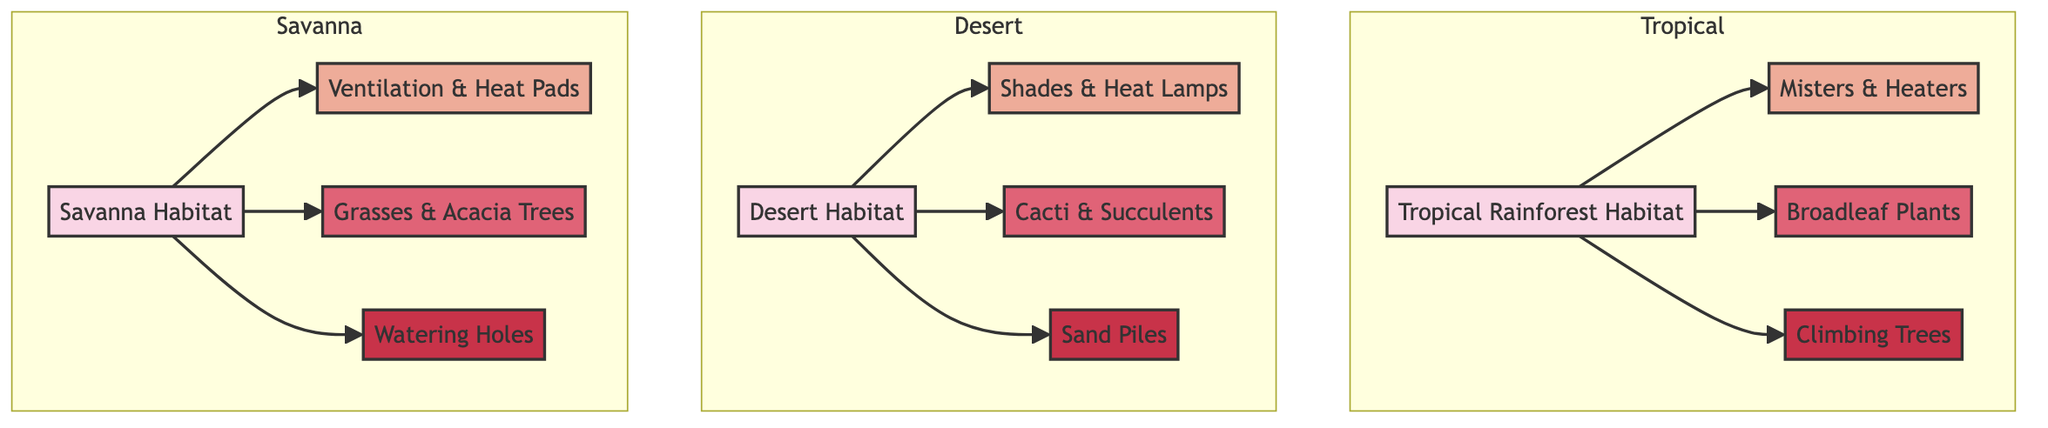What habitats are represented in the diagram? The diagram shows three habitats: Tropical Rainforest Habitat, Desert Habitat, and Savanna Habitat. These are clearly labeled as separate nodes on the diagram.
Answer: Tropical Rainforest, Desert, Savanna How many climate control methods are listed in the diagram? There are three climate control methods provided in the diagram, which are Misters & Heaters, Shades & Heat Lamps, and Ventilation & Heat Pads. Each method corresponds to a specific habitat.
Answer: 3 Which foliage is associated with the Desert Habitat? The Desert Habitat is linked to the Cacti & Succulents node as its specific foliage. This relationship is highlighted in the diagram.
Answer: Cacti & Succulents What type of enrichment activities are provided for the Tropical Rainforest Habitat? The Tropical Rainforest Habitat includes Climbing Trees as the enrichment activity, demonstrated through the direct connection in the diagram.
Answer: Climbing Trees Which habitat utilizes Ventilation & Heat Pads for climate control? The Savanna Habitat uses Ventilation & Heat Pads as its climate control method, as indicated by the direct link between the habitat and this climate control method in the diagram.
Answer: Savanna Habitat How many types of foliage are depicted in the diagram? The diagram shows three types of foliage, one for each habitat: Broadleaf Plants, Cacti & Succulents, and Grasses & Acacia Trees. These correspond with their respective habitats.
Answer: 3 Which enrichment activity is featured in the Savanna Habitat? The Savanna Habitat includes Watering Holes as its designated enrichment activity, which is clearly indicated in the diagram's structure.
Answer: Watering Holes Which habitat has Shades & Heat Lamps as climate control? The Desert Habitat utilizes Shades & Heat Lamps for climate control, which is explicitly noted in the relationships shown in the diagram.
Answer: Desert Habitat What is the relationship between the Desert Habitat and its foliage? The Desert Habitat is related to Cacti & Succulents, showing a direct connection in the diagram that illustrates the specific foliage for this environment.
Answer: Cacti & Succulents 